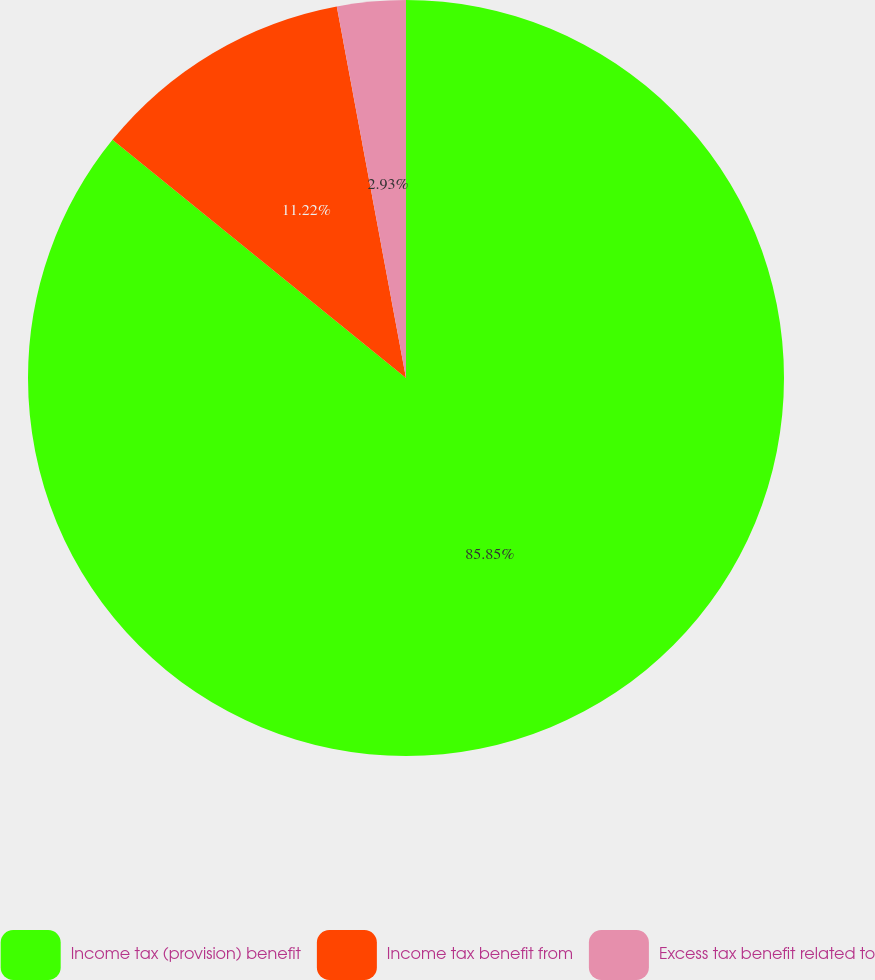Convert chart. <chart><loc_0><loc_0><loc_500><loc_500><pie_chart><fcel>Income tax (provision) benefit<fcel>Income tax benefit from<fcel>Excess tax benefit related to<nl><fcel>85.84%<fcel>11.22%<fcel>2.93%<nl></chart> 